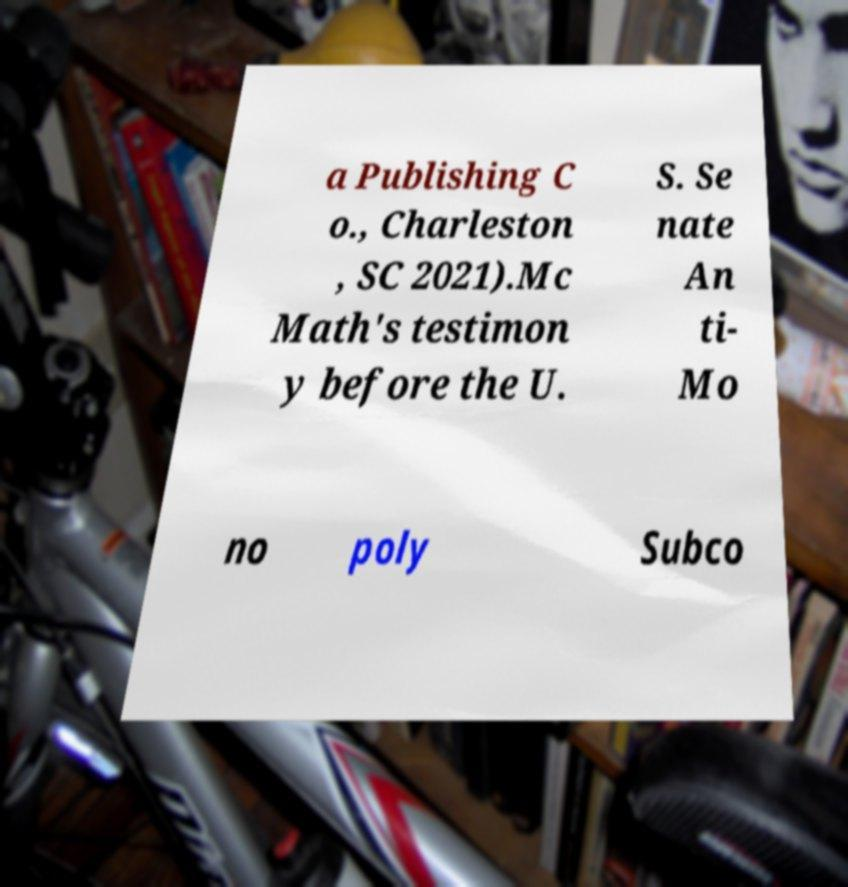Please read and relay the text visible in this image. What does it say? a Publishing C o., Charleston , SC 2021).Mc Math's testimon y before the U. S. Se nate An ti- Mo no poly Subco 